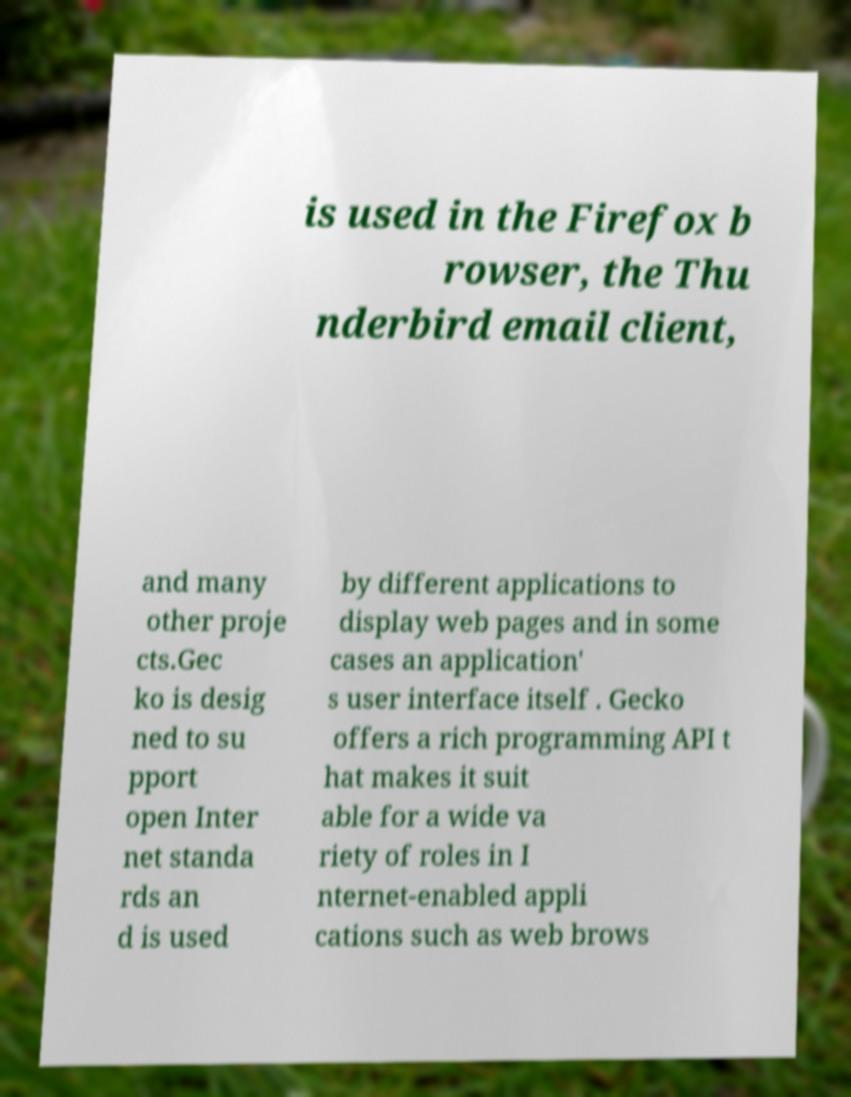Can you read and provide the text displayed in the image?This photo seems to have some interesting text. Can you extract and type it out for me? is used in the Firefox b rowser, the Thu nderbird email client, and many other proje cts.Gec ko is desig ned to su pport open Inter net standa rds an d is used by different applications to display web pages and in some cases an application' s user interface itself . Gecko offers a rich programming API t hat makes it suit able for a wide va riety of roles in I nternet-enabled appli cations such as web brows 